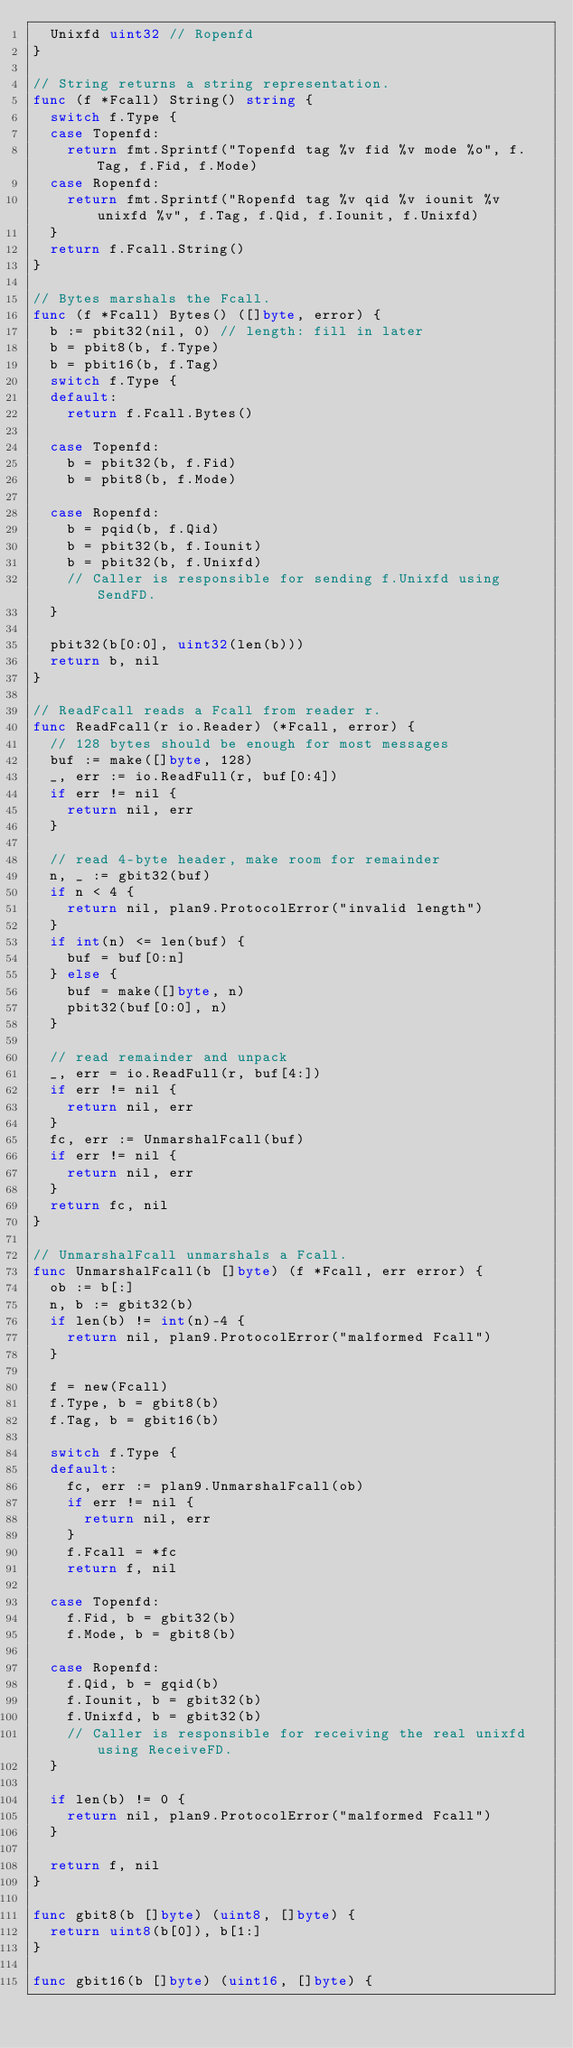Convert code to text. <code><loc_0><loc_0><loc_500><loc_500><_Go_>	Unixfd uint32 // Ropenfd
}

// String returns a string representation.
func (f *Fcall) String() string {
	switch f.Type {
	case Topenfd:
		return fmt.Sprintf("Topenfd tag %v fid %v mode %o", f.Tag, f.Fid, f.Mode)
	case Ropenfd:
		return fmt.Sprintf("Ropenfd tag %v qid %v iounit %v unixfd %v", f.Tag, f.Qid, f.Iounit, f.Unixfd)
	}
	return f.Fcall.String()
}

// Bytes marshals the Fcall.
func (f *Fcall) Bytes() ([]byte, error) {
	b := pbit32(nil, 0) // length: fill in later
	b = pbit8(b, f.Type)
	b = pbit16(b, f.Tag)
	switch f.Type {
	default:
		return f.Fcall.Bytes()

	case Topenfd:
		b = pbit32(b, f.Fid)
		b = pbit8(b, f.Mode)

	case Ropenfd:
		b = pqid(b, f.Qid)
		b = pbit32(b, f.Iounit)
		b = pbit32(b, f.Unixfd)
		// Caller is responsible for sending f.Unixfd using SendFD.
	}

	pbit32(b[0:0], uint32(len(b)))
	return b, nil
}

// ReadFcall reads a Fcall from reader r.
func ReadFcall(r io.Reader) (*Fcall, error) {
	// 128 bytes should be enough for most messages
	buf := make([]byte, 128)
	_, err := io.ReadFull(r, buf[0:4])
	if err != nil {
		return nil, err
	}

	// read 4-byte header, make room for remainder
	n, _ := gbit32(buf)
	if n < 4 {
		return nil, plan9.ProtocolError("invalid length")
	}
	if int(n) <= len(buf) {
		buf = buf[0:n]
	} else {
		buf = make([]byte, n)
		pbit32(buf[0:0], n)
	}

	// read remainder and unpack
	_, err = io.ReadFull(r, buf[4:])
	if err != nil {
		return nil, err
	}
	fc, err := UnmarshalFcall(buf)
	if err != nil {
		return nil, err
	}
	return fc, nil
}

// UnmarshalFcall unmarshals a Fcall.
func UnmarshalFcall(b []byte) (f *Fcall, err error) {
	ob := b[:]
	n, b := gbit32(b)
	if len(b) != int(n)-4 {
		return nil, plan9.ProtocolError("malformed Fcall")
	}

	f = new(Fcall)
	f.Type, b = gbit8(b)
	f.Tag, b = gbit16(b)

	switch f.Type {
	default:
		fc, err := plan9.UnmarshalFcall(ob)
		if err != nil {
			return nil, err
		}
		f.Fcall = *fc
		return f, nil

	case Topenfd:
		f.Fid, b = gbit32(b)
		f.Mode, b = gbit8(b)

	case Ropenfd:
		f.Qid, b = gqid(b)
		f.Iounit, b = gbit32(b)
		f.Unixfd, b = gbit32(b)
		// Caller is responsible for receiving the real unixfd using ReceiveFD.
	}

	if len(b) != 0 {
		return nil, plan9.ProtocolError("malformed Fcall")
	}

	return f, nil
}

func gbit8(b []byte) (uint8, []byte) {
	return uint8(b[0]), b[1:]
}

func gbit16(b []byte) (uint16, []byte) {</code> 